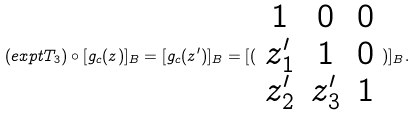<formula> <loc_0><loc_0><loc_500><loc_500>( e x p t T _ { 3 } ) \circ [ g _ { c } ( z ) ] _ { B } = [ g _ { c } ( z ^ { \prime } ) ] _ { B } = [ ( \begin{array} { c c c } 1 & 0 & 0 \\ z _ { 1 } ^ { \prime } & 1 & 0 \\ z _ { 2 } ^ { \prime } & z _ { 3 } ^ { \prime } & 1 \end{array} ) ] _ { B } .</formula> 